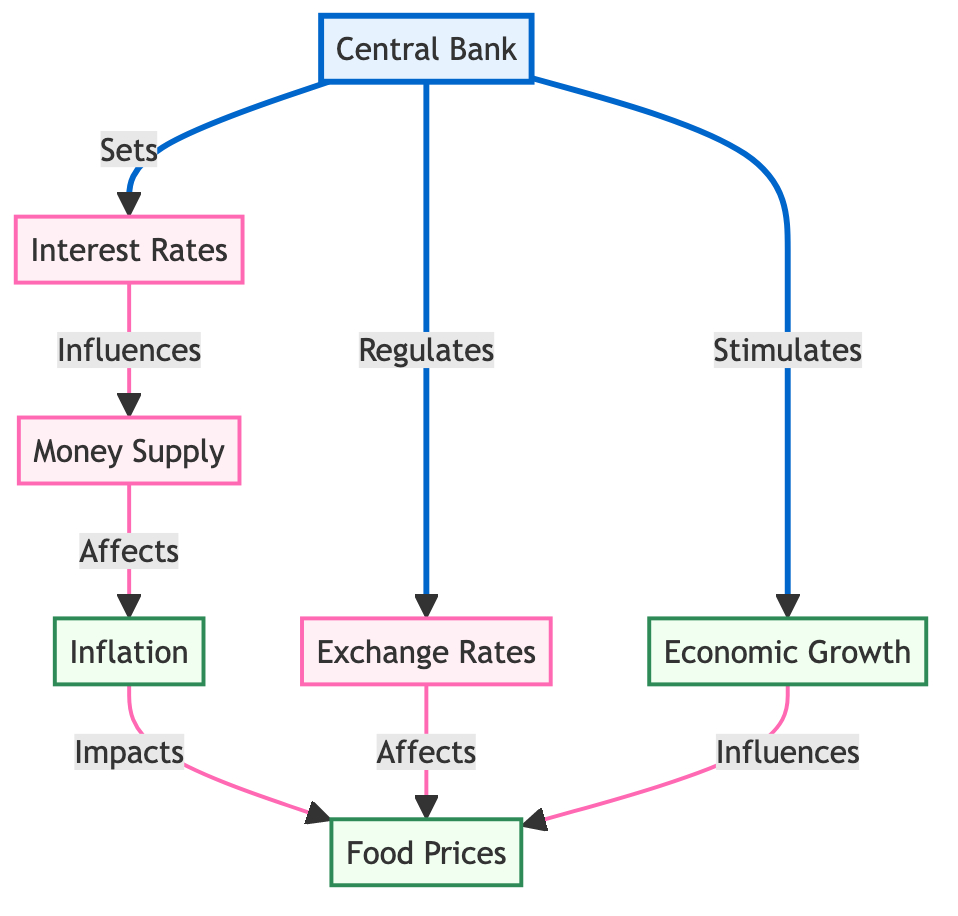What is the central node in the diagram? The central node in the diagram is the Central Bank, as it is the main entity influencing various other components in the flow.
Answer: Central Bank How many policy nodes are present in the diagram? There are four policy nodes in the diagram, which are Interest Rates, Money Supply, Exchange Rates, and Food Prices.
Answer: Four What does the Central Bank regulate? The Central Bank regulates Exchange Rates, as indicated by the direct connection from the Central Bank to Exchange Rates in the diagram.
Answer: Exchange Rates Which node is influenced by Economic Growth? Food Prices are influenced by Economic Growth, based on the flow from Economic Growth to Food Prices in the diagram.
Answer: Food Prices What is a consequence of the Central Bank setting Interest Rates? When the Central Bank sets Interest Rates, it influences Money Supply. This is a direct consequence of the flow from Interest Rates to Money Supply.
Answer: Money Supply How does Inflation affect Food Prices? Inflation impacts Food Prices, as shown by the connection from Inflation to Food Prices in the diagram. This indicates that as inflation increases, food prices are likely to be affected similarly.
Answer: Food Prices What does the Money Supply affect? Money Supply affects Inflation, based on the flow from Money Supply to Inflation in the diagram. This indicates that changes in the money supply can directly impact inflation levels.
Answer: Inflation If the Central Bank stimulates Economic Growth, what is its effect on Food Prices? Stimulating Economic Growth influences Food Prices, as expressed by the link from Economic Growth to Food Prices in the diagram. This shows that an increase in economic growth would likely lead to an influence on food prices as well.
Answer: Food Prices Which node has a direct connection to the Exchange Rates? The Central Bank has a direct connection to the Exchange Rates, indicating its regulatory role over this economic factor.
Answer: Central Bank 